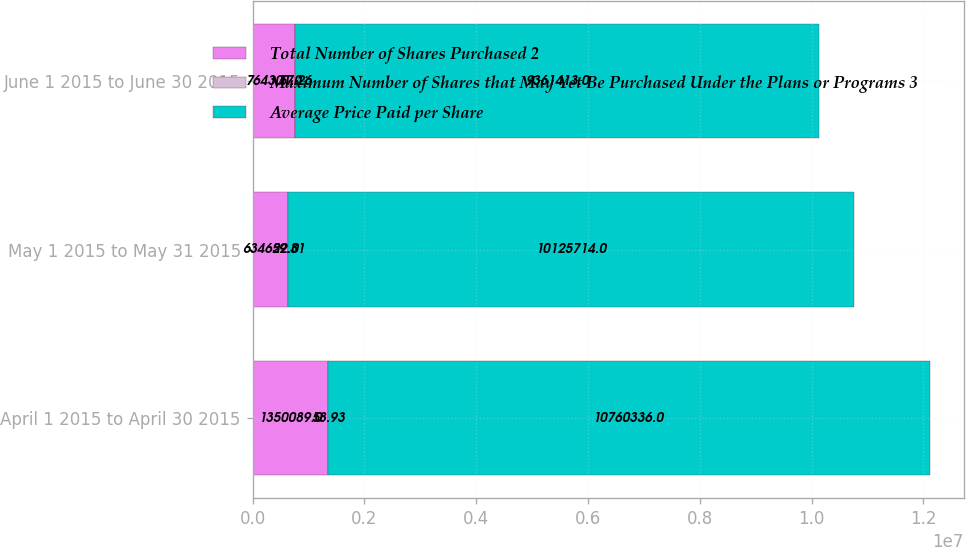Convert chart to OTSL. <chart><loc_0><loc_0><loc_500><loc_500><stacked_bar_chart><ecel><fcel>April 1 2015 to April 30 2015<fcel>May 1 2015 to May 31 2015<fcel>June 1 2015 to June 30 2015<nl><fcel>Total Number of Shares Purchased 2<fcel>1.35009e+06<fcel>634622<fcel>764301<nl><fcel>Maximum Number of Shares that May Yet Be Purchased Under the Plans or Programs 3<fcel>58.93<fcel>59.31<fcel>57.26<nl><fcel>Average Price Paid per Share<fcel>1.07603e+07<fcel>1.01257e+07<fcel>9.36141e+06<nl></chart> 